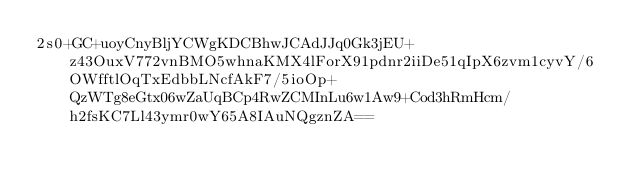<code> <loc_0><loc_0><loc_500><loc_500><_SML_>2s0+GC+uoyCnyBljYCWgKDCBhwJCAdJJq0Gk3jEU+z43OuxV772vnBMO5whnaKMX4lForX91pdnr2iiDe51qIpX6zvm1cyvY/6OWfftlOqTxEdbbLNcfAkF7/5ioOp+QzWTg8eGtx06wZaUqBCp4RwZCMInLu6w1Aw9+Cod3hRmHcm/h2fsKC7Ll43ymr0wY65A8IAuNQgznZA==</code> 